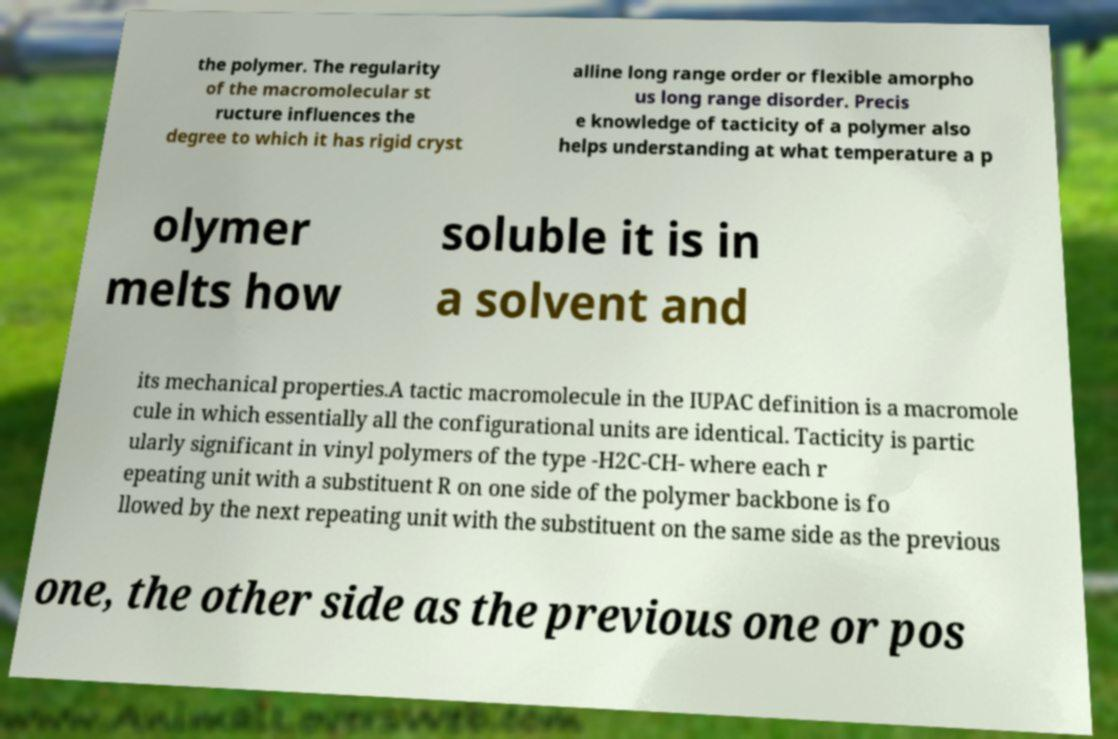There's text embedded in this image that I need extracted. Can you transcribe it verbatim? the polymer. The regularity of the macromolecular st ructure influences the degree to which it has rigid cryst alline long range order or flexible amorpho us long range disorder. Precis e knowledge of tacticity of a polymer also helps understanding at what temperature a p olymer melts how soluble it is in a solvent and its mechanical properties.A tactic macromolecule in the IUPAC definition is a macromole cule in which essentially all the configurational units are identical. Tacticity is partic ularly significant in vinyl polymers of the type -H2C-CH- where each r epeating unit with a substituent R on one side of the polymer backbone is fo llowed by the next repeating unit with the substituent on the same side as the previous one, the other side as the previous one or pos 